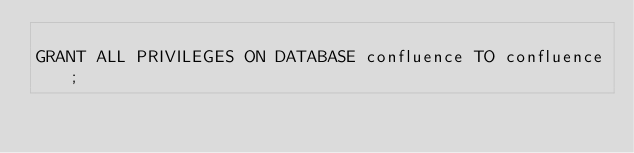<code> <loc_0><loc_0><loc_500><loc_500><_SQL_>
GRANT ALL PRIVILEGES ON DATABASE confluence TO confluence;
</code> 